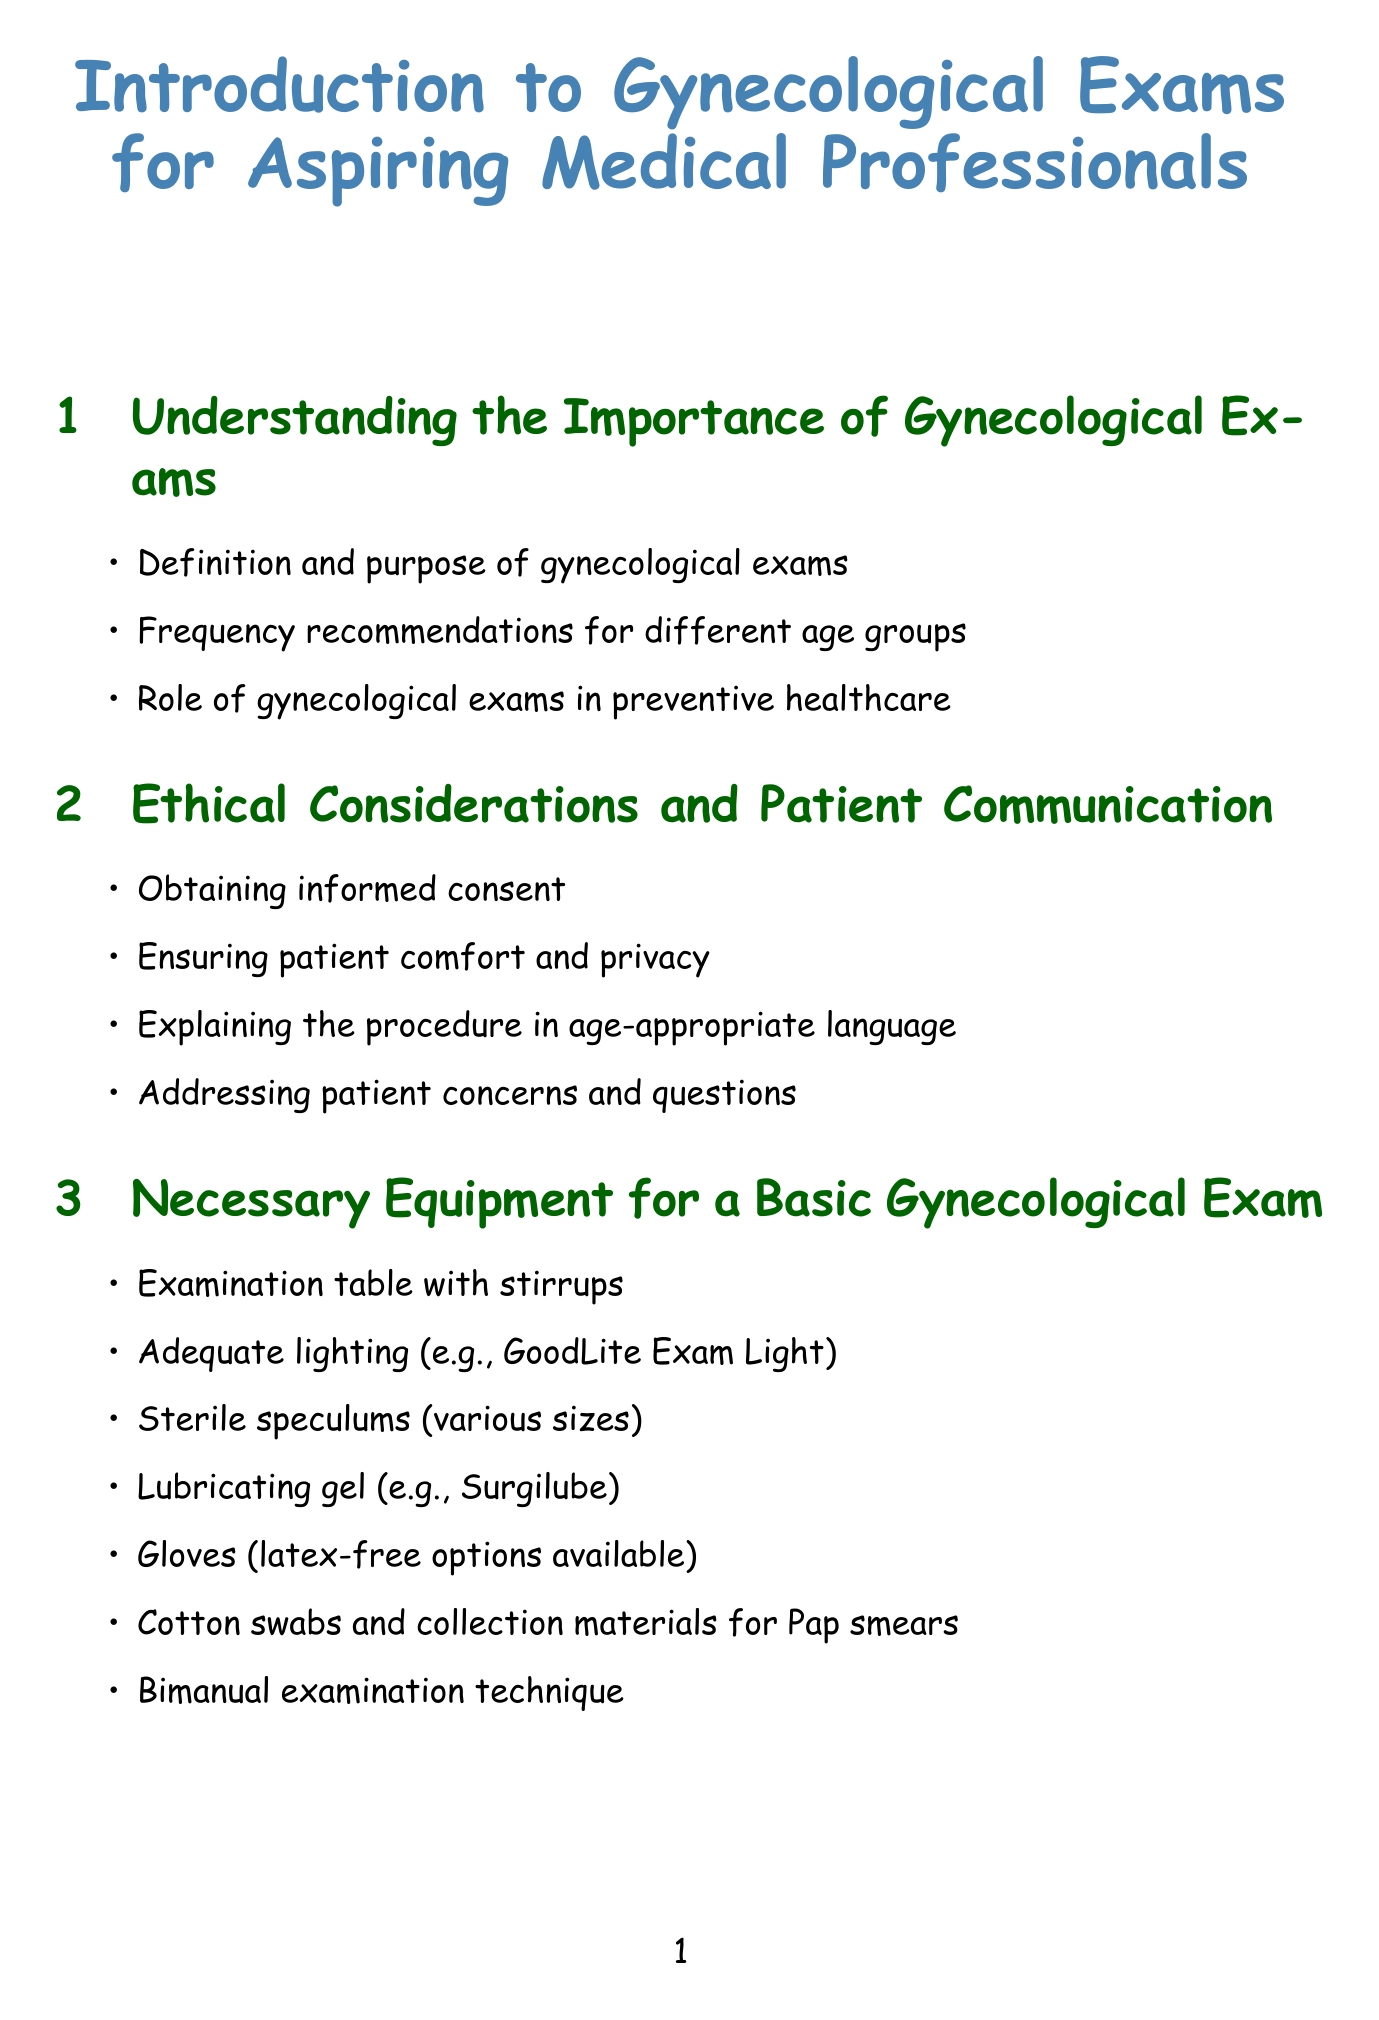What is the title of the manual? The title is mentioned at the beginning of the document, providing an introduction to gynecological exams.
Answer: Introduction to Gynecological Exams for Aspiring Medical Professionals How many sections are in the manual? By reviewing the structured list of sections in the document, we can count them.
Answer: 8 What is one type of necessary equipment for a gynecological exam? The document lists specific equipment needed for the examination procedure.
Answer: Sterile speculums What should be addressed in patient communication? The manual highlights important points regarding communication with patients before a gynecological exam.
Answer: Informed consent What is emphasized in post-examination care? The content outlines specific actions to take after the examination for the patient's well-being.
Answer: Immediate feedback What special considerations are mentioned for adolescent patients? This information is specifically targeted at modifying the exam process for younger patients.
Answer: Privacy concerns Which textbook is recommended in the learning resources? The manual suggests specific textbooks that are beneficial for aspiring gynecologists.
Answer: Comprehensive Gynecology by Lobo et al What is the importance of gynecological exams? The document conveys the essential role of these exams in patient health care.
Answer: Preventive healthcare 